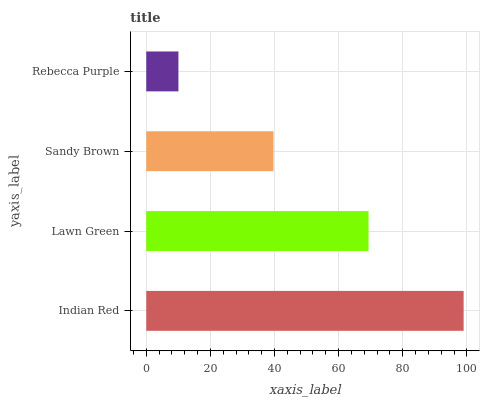Is Rebecca Purple the minimum?
Answer yes or no. Yes. Is Indian Red the maximum?
Answer yes or no. Yes. Is Lawn Green the minimum?
Answer yes or no. No. Is Lawn Green the maximum?
Answer yes or no. No. Is Indian Red greater than Lawn Green?
Answer yes or no. Yes. Is Lawn Green less than Indian Red?
Answer yes or no. Yes. Is Lawn Green greater than Indian Red?
Answer yes or no. No. Is Indian Red less than Lawn Green?
Answer yes or no. No. Is Lawn Green the high median?
Answer yes or no. Yes. Is Sandy Brown the low median?
Answer yes or no. Yes. Is Indian Red the high median?
Answer yes or no. No. Is Rebecca Purple the low median?
Answer yes or no. No. 